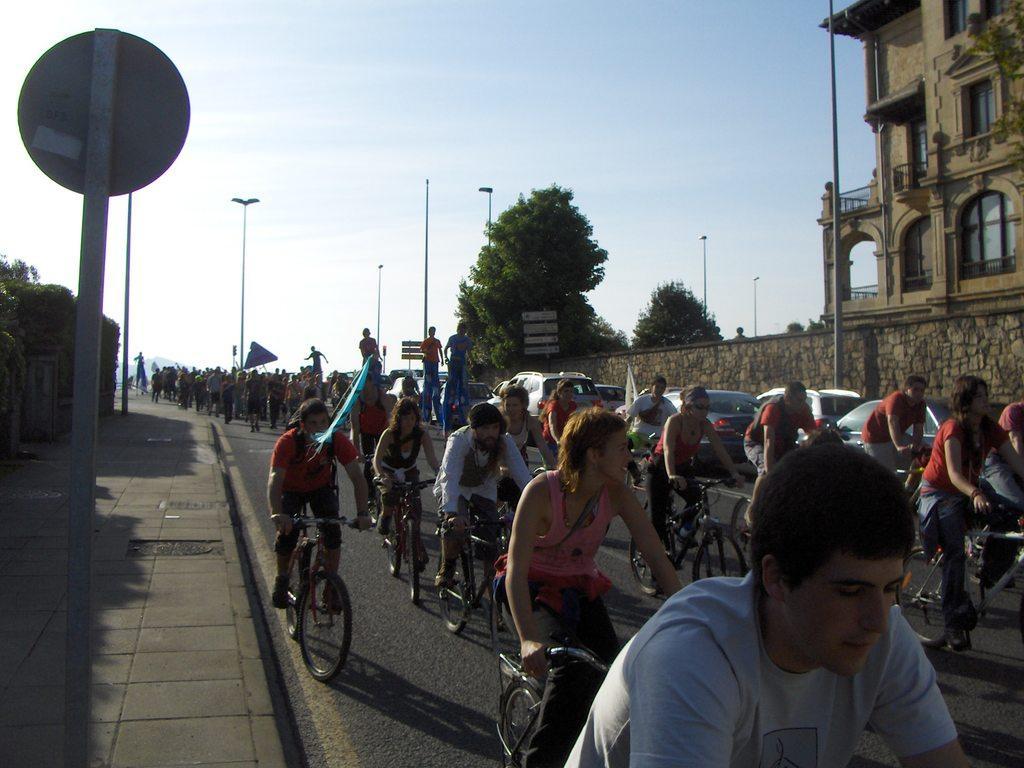Please provide a concise description of this image. in this picture we can see people riding the bicycle on the roads,we can also see trees and clear sky,we can see poles street lights and here we can also see building. 